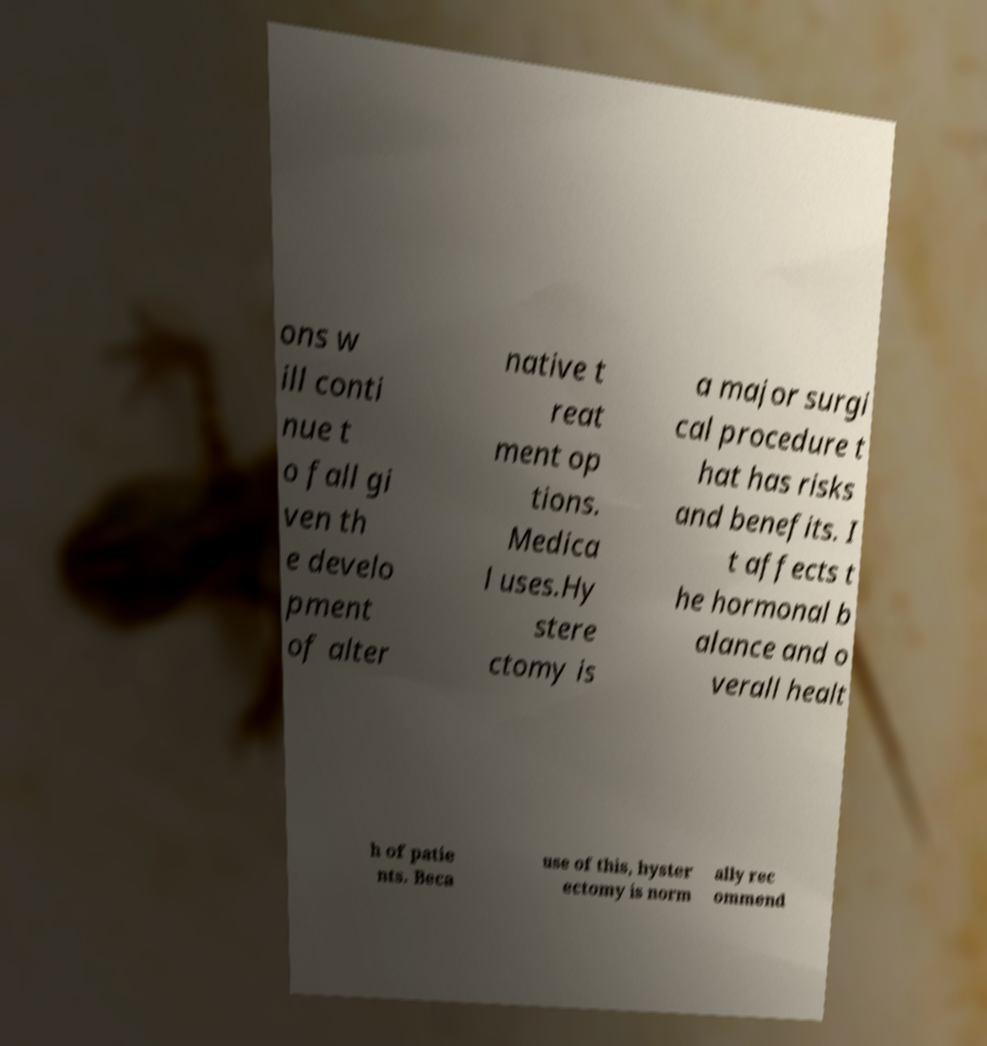There's text embedded in this image that I need extracted. Can you transcribe it verbatim? ons w ill conti nue t o fall gi ven th e develo pment of alter native t reat ment op tions. Medica l uses.Hy stere ctomy is a major surgi cal procedure t hat has risks and benefits. I t affects t he hormonal b alance and o verall healt h of patie nts. Beca use of this, hyster ectomy is norm ally rec ommend 